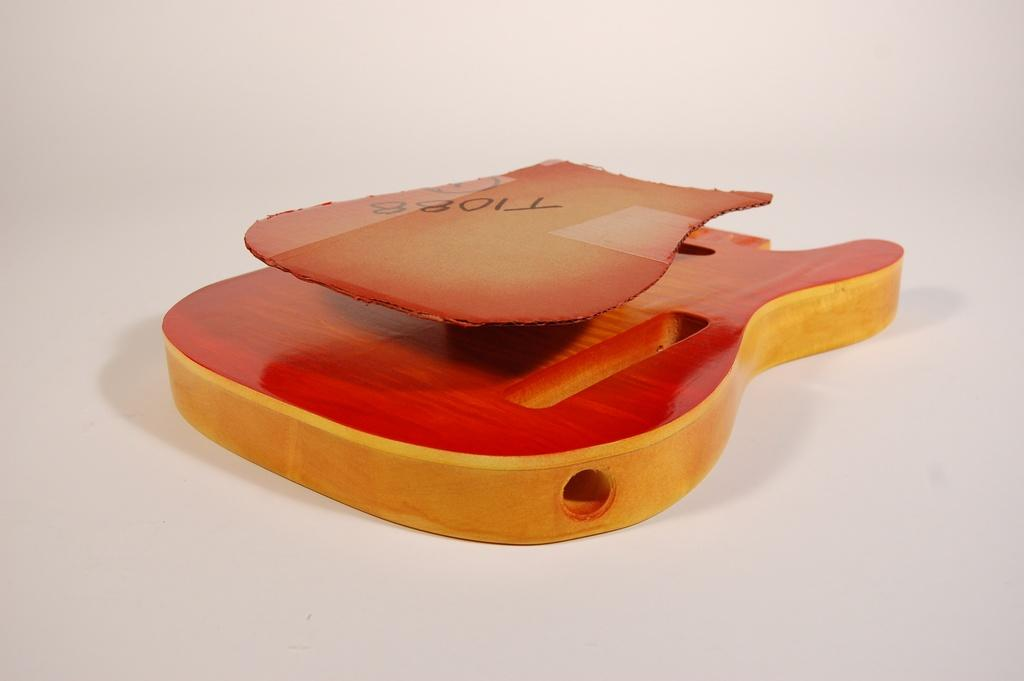What type of musical instrument is depicted in the image? There is a wooden object in the shape of a guitar in the image. What else can be seen in the image besides the guitar? There is a cardboard sheet with letters on it. What is the color of the background in the image? The background appears to be white in color. What type of news can be seen on the cardboard sheet in the image? There is no news present on the cardboard sheet in the image; it only has letters on it. Are there any pests visible in the image? There are no pests visible in the image. 